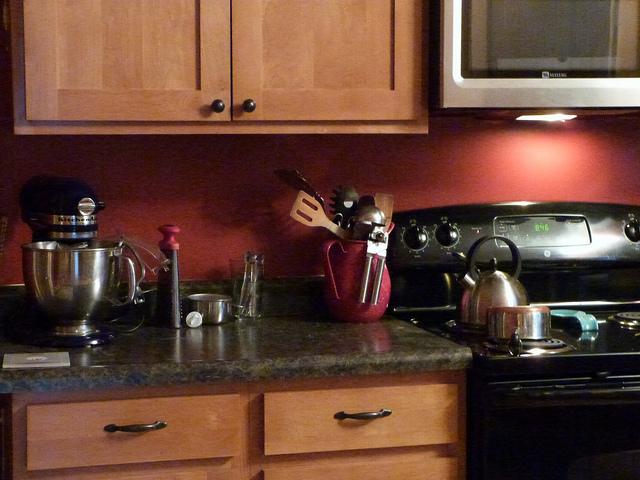What color is the oven?
Keep it brief. Black. Is this kitchen modern?
Keep it brief. Yes. What is the purpose of the item to the far left?
Short answer required. Mixing. 